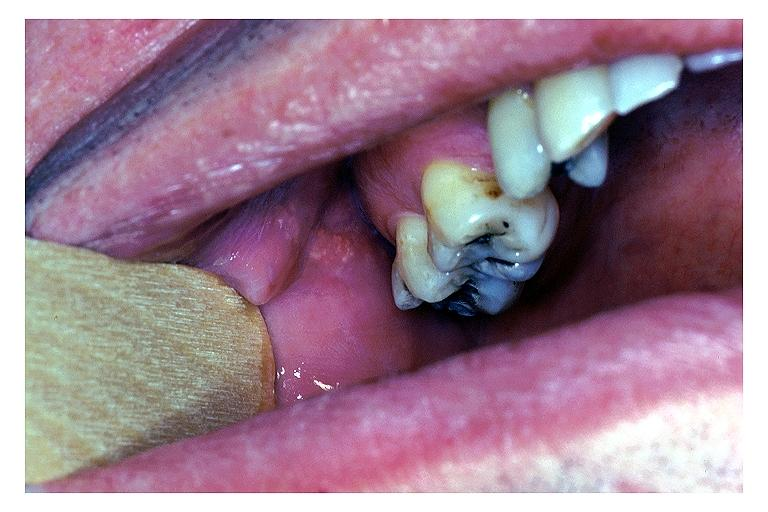what does this image show?
Answer the question using a single word or phrase. Fordyce granules 